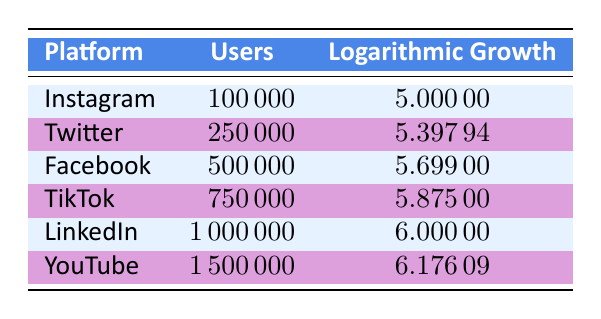What is the platform with the highest number of users? By examining the "Users" column, we find that YouTube has the highest value at 1,500,000 users.
Answer: YouTube What is the logarithmic growth value for TikTok? The table shows that TikTok's logarithmic growth is 5.875.
Answer: 5.875 Which platform has a logarithmic growth value closer to 6 than 5? Looking at the logarithmic growth values, LinkedIn (6.0) and YouTube (6.17609) are closer to 6, while others, like Instagram (5.0) and Twitter (5.39794), are closer to 5. So, LinkedIn and YouTube meet this criterion.
Answer: LinkedIn, YouTube What is the difference in users between Facebook and Twitter? Facebook has 500,000 users, and Twitter has 250,000 users. The difference is 500,000 - 250,000 = 250,000.
Answer: 250000 Is TikTok the platform with the lowest logarithmic growth value? By comparing the logarithmic growth values, Instagram has the lowest at 5.0, which is lower than TikTok's value of 5.875. Therefore, the statement is false.
Answer: No What is the average logarithmic growth of all platforms in the table? Adding the logarithmic growth values together: 5.00000 + 5.39794 + 5.69900 + 5.87500 + 6.00000 + 6.17609 = 34.14803. There are 6 platforms, so the average is 34.14803 / 6 = 5.69134.
Answer: 5.69134 Which platform has more than 500,000 users and what is its logarithmic growth? The platforms with more than 500,000 users are TikTok (750,000; 5.875), LinkedIn (1,000,000; 6.000), and YouTube (1,500,000; 6.17609). This shows three platforms that meet the criteria.
Answer: TikTok, LinkedIn, YouTube Is Twitter's logarithmic growth greater than Facebook's? Checking the values, Twitter has a logarithmic growth of 5.39794, while Facebook's is 5.69900. Since 5.39794 < 5.69900, the statement is false.
Answer: No What is the total number of users for Instagram and LinkedIn combined? Instagram has 100,000 users and LinkedIn has 1,000,000 users. Adding them gives 100,000 + 1,000,000 = 1,100,000.
Answer: 1100000 